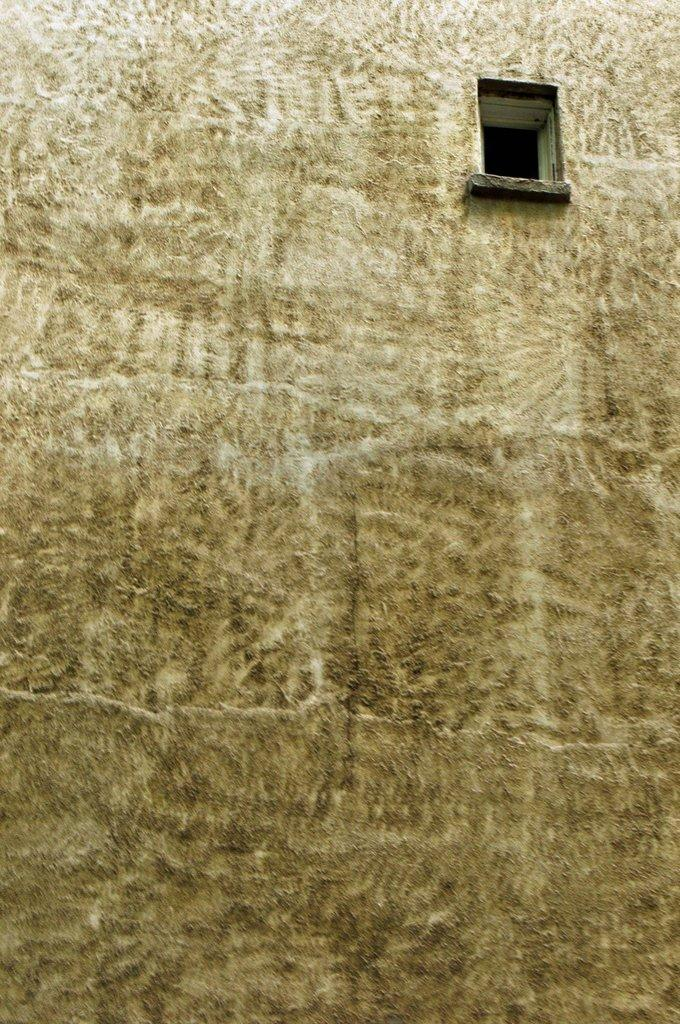What is a prominent feature in the image? There is a wall in the image. Can you describe any openings or features in the wall? There is a window in the wall. What story is being told through the window in the image? There is no story being told through the window in the image; it is simply a window in a wall. Can you explain the arithmetic problem that is being solved on the wall in the image? There is no arithmetic problem visible in the image; it only features a wall with a window. 